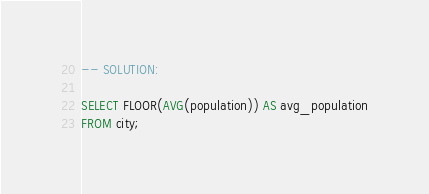<code> <loc_0><loc_0><loc_500><loc_500><_SQL_>

-- SOLUTION:

SELECT FLOOR(AVG(population)) AS avg_population
FROM city;</code> 